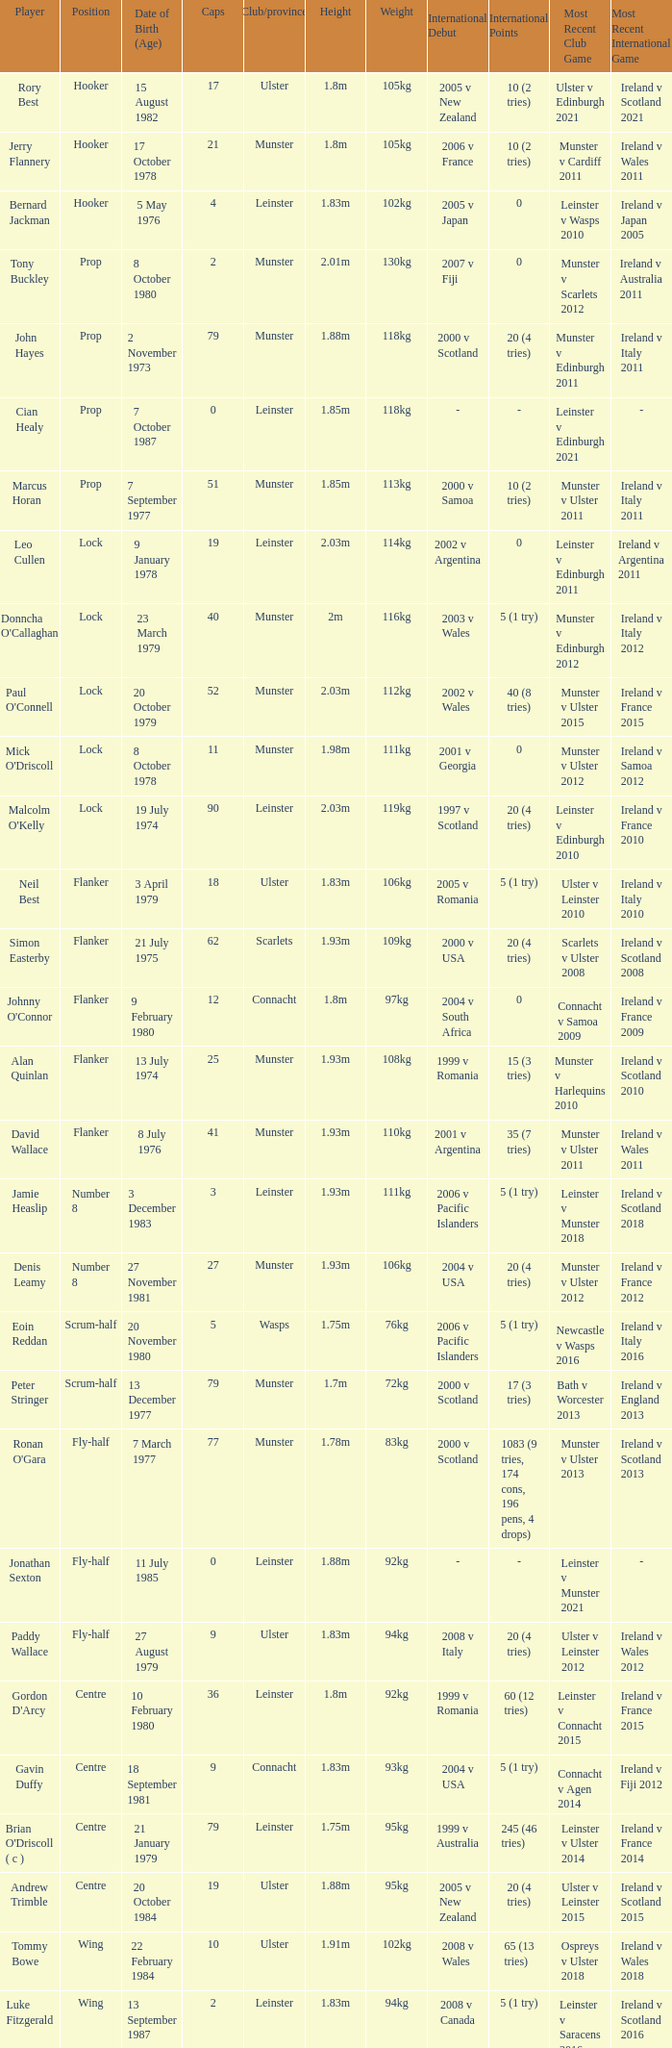What is the total of Caps when player born 13 December 1977? 79.0. 